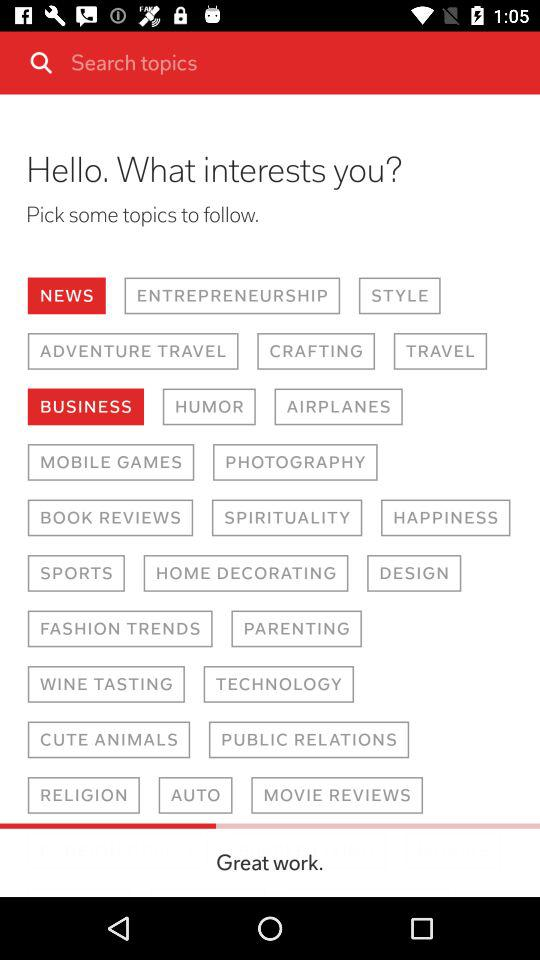Which option is selected for interests? The selected options for interests are "NEWS" and "BUSINESS". 